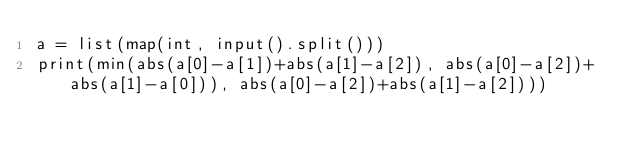Convert code to text. <code><loc_0><loc_0><loc_500><loc_500><_Python_>a = list(map(int, input().split()))
print(min(abs(a[0]-a[1])+abs(a[1]-a[2]), abs(a[0]-a[2])+abs(a[1]-a[0])), abs(a[0]-a[2])+abs(a[1]-a[2])))
</code> 